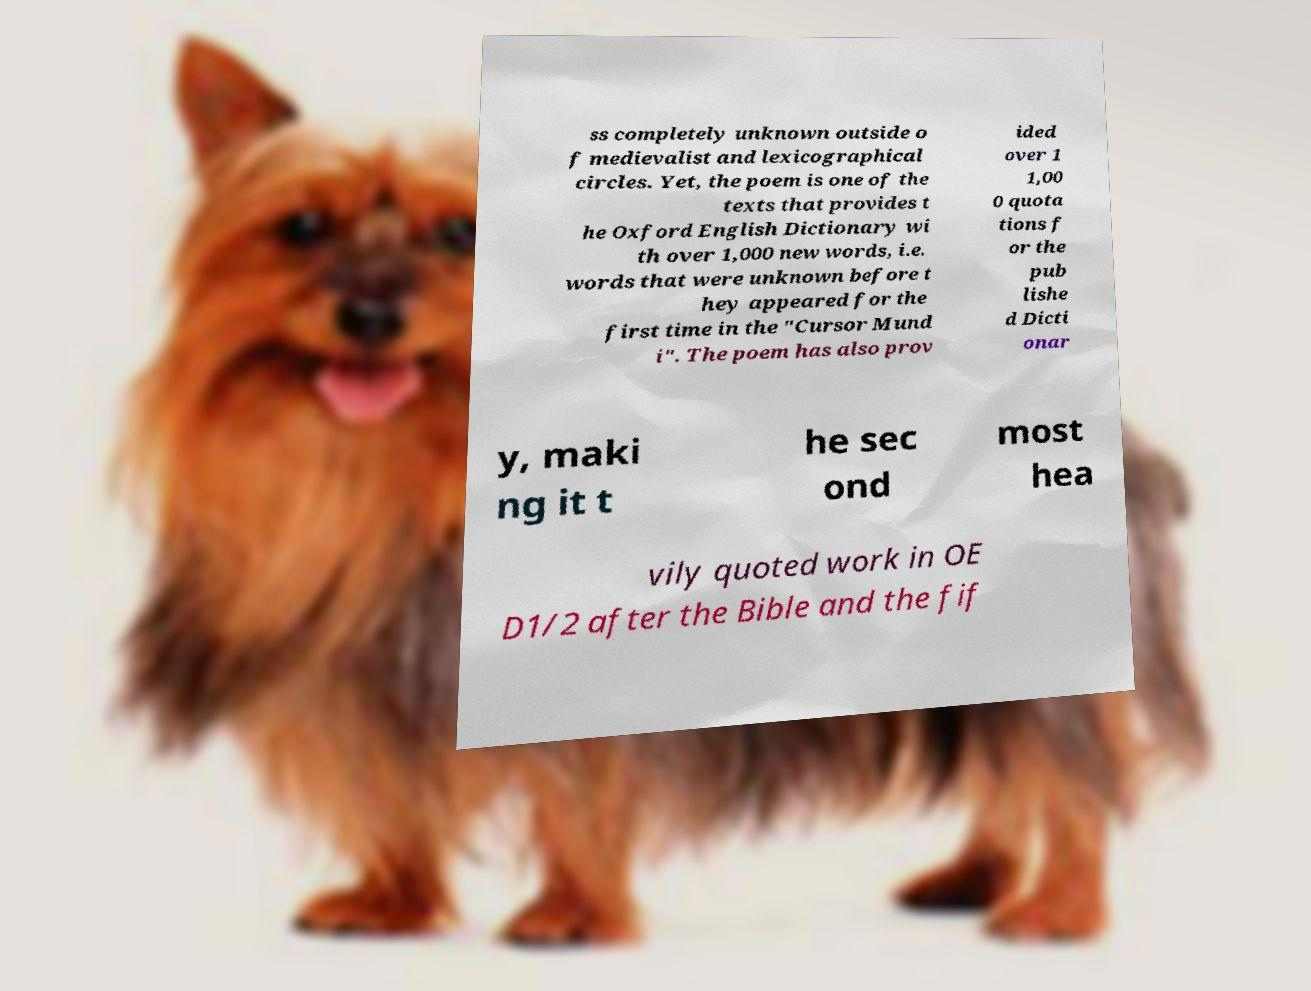Please identify and transcribe the text found in this image. ss completely unknown outside o f medievalist and lexicographical circles. Yet, the poem is one of the texts that provides t he Oxford English Dictionary wi th over 1,000 new words, i.e. words that were unknown before t hey appeared for the first time in the "Cursor Mund i". The poem has also prov ided over 1 1,00 0 quota tions f or the pub lishe d Dicti onar y, maki ng it t he sec ond most hea vily quoted work in OE D1/2 after the Bible and the fif 